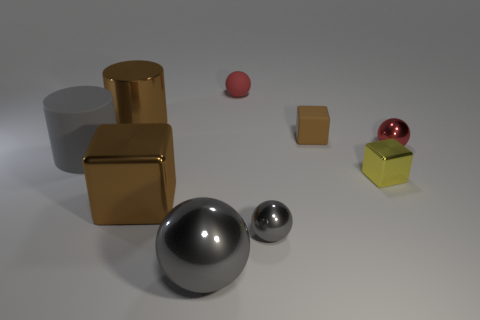There is another cube that is the same color as the rubber cube; what is its size?
Make the answer very short. Large. There is a big brown metal thing right of the brown shiny cylinder; what shape is it?
Give a very brief answer. Cube. How many other things are the same material as the tiny brown cube?
Your answer should be very brief. 2. What size is the yellow metallic thing?
Make the answer very short. Small. What number of other objects are the same color as the metallic cylinder?
Ensure brevity in your answer.  2. There is a tiny object that is on the left side of the brown rubber thing and behind the red metallic object; what is its color?
Provide a succinct answer. Red. How many tiny matte spheres are there?
Your response must be concise. 1. Is the material of the gray cylinder the same as the large gray sphere?
Give a very brief answer. No. What is the shape of the shiny thing on the left side of the brown object that is in front of the tiny block behind the gray cylinder?
Offer a very short reply. Cylinder. Is the sphere to the right of the yellow metallic object made of the same material as the brown block in front of the rubber cylinder?
Provide a succinct answer. Yes. 